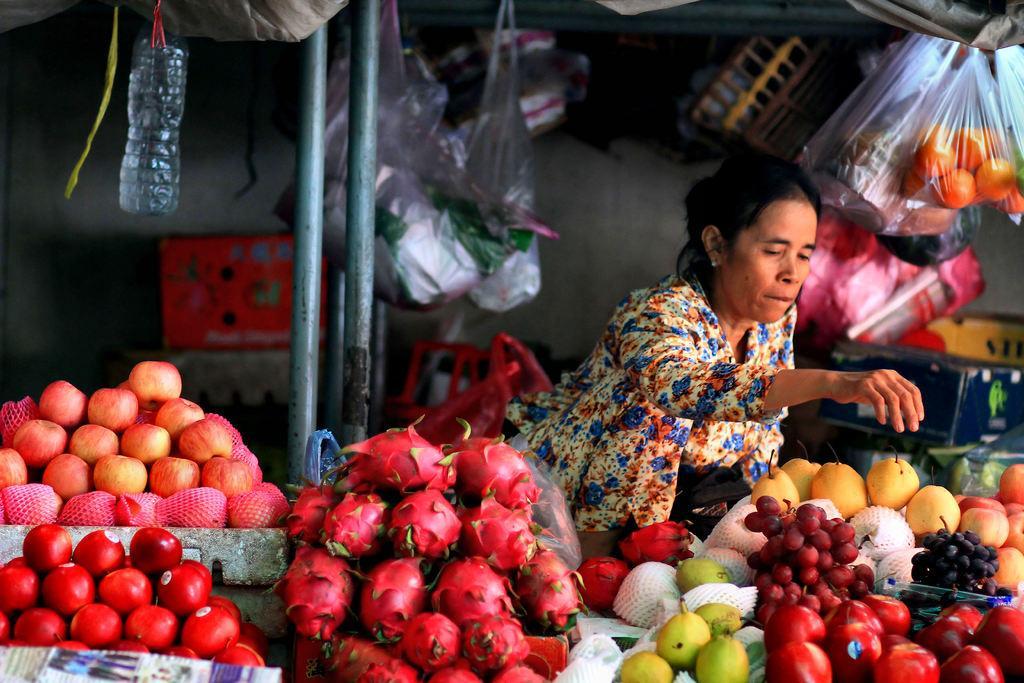Please provide a concise description of this image. In This picture we can see fruit stall with red apples, bunch of Dragon fruits, pears, red and black grapes. Behind we can see a woman wearing colorful dress sitting on the fruit stall. Above we can see some covers hanging. On the left side we can see plastic water bottle hanging from the top shed. 